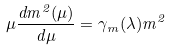Convert formula to latex. <formula><loc_0><loc_0><loc_500><loc_500>\mu \frac { d m ^ { 2 } ( \mu ) } { d \mu } = \gamma _ { m } ( \lambda ) m ^ { 2 }</formula> 